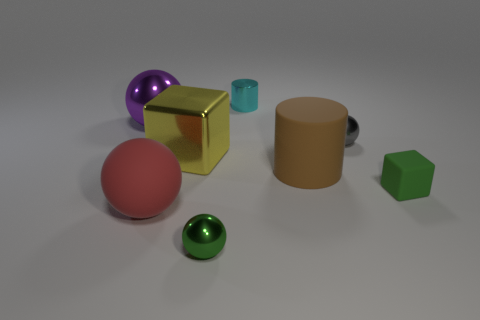What number of cylinders are the same size as the gray metallic ball?
Ensure brevity in your answer.  1. Is the number of tiny metal balls that are in front of the large brown rubber cylinder greater than the number of small cyan objects that are in front of the cyan metallic cylinder?
Give a very brief answer. Yes. There is a block that is the same size as the gray shiny object; what is its material?
Keep it short and to the point. Rubber. What is the shape of the purple object?
Offer a very short reply. Sphere. What number of brown things are small shiny spheres or large objects?
Your response must be concise. 1. There is a yellow thing that is made of the same material as the tiny cyan object; what is its size?
Offer a very short reply. Large. Is the block to the left of the tiny cyan metallic cylinder made of the same material as the cylinder on the left side of the large brown cylinder?
Offer a terse response. Yes. What number of blocks are large blue shiny objects or metallic things?
Your response must be concise. 1. How many metallic blocks are on the left side of the ball that is left of the large rubber object that is in front of the tiny green matte block?
Your answer should be very brief. 0. There is a red object that is the same shape as the green metallic object; what material is it?
Provide a short and direct response. Rubber. 